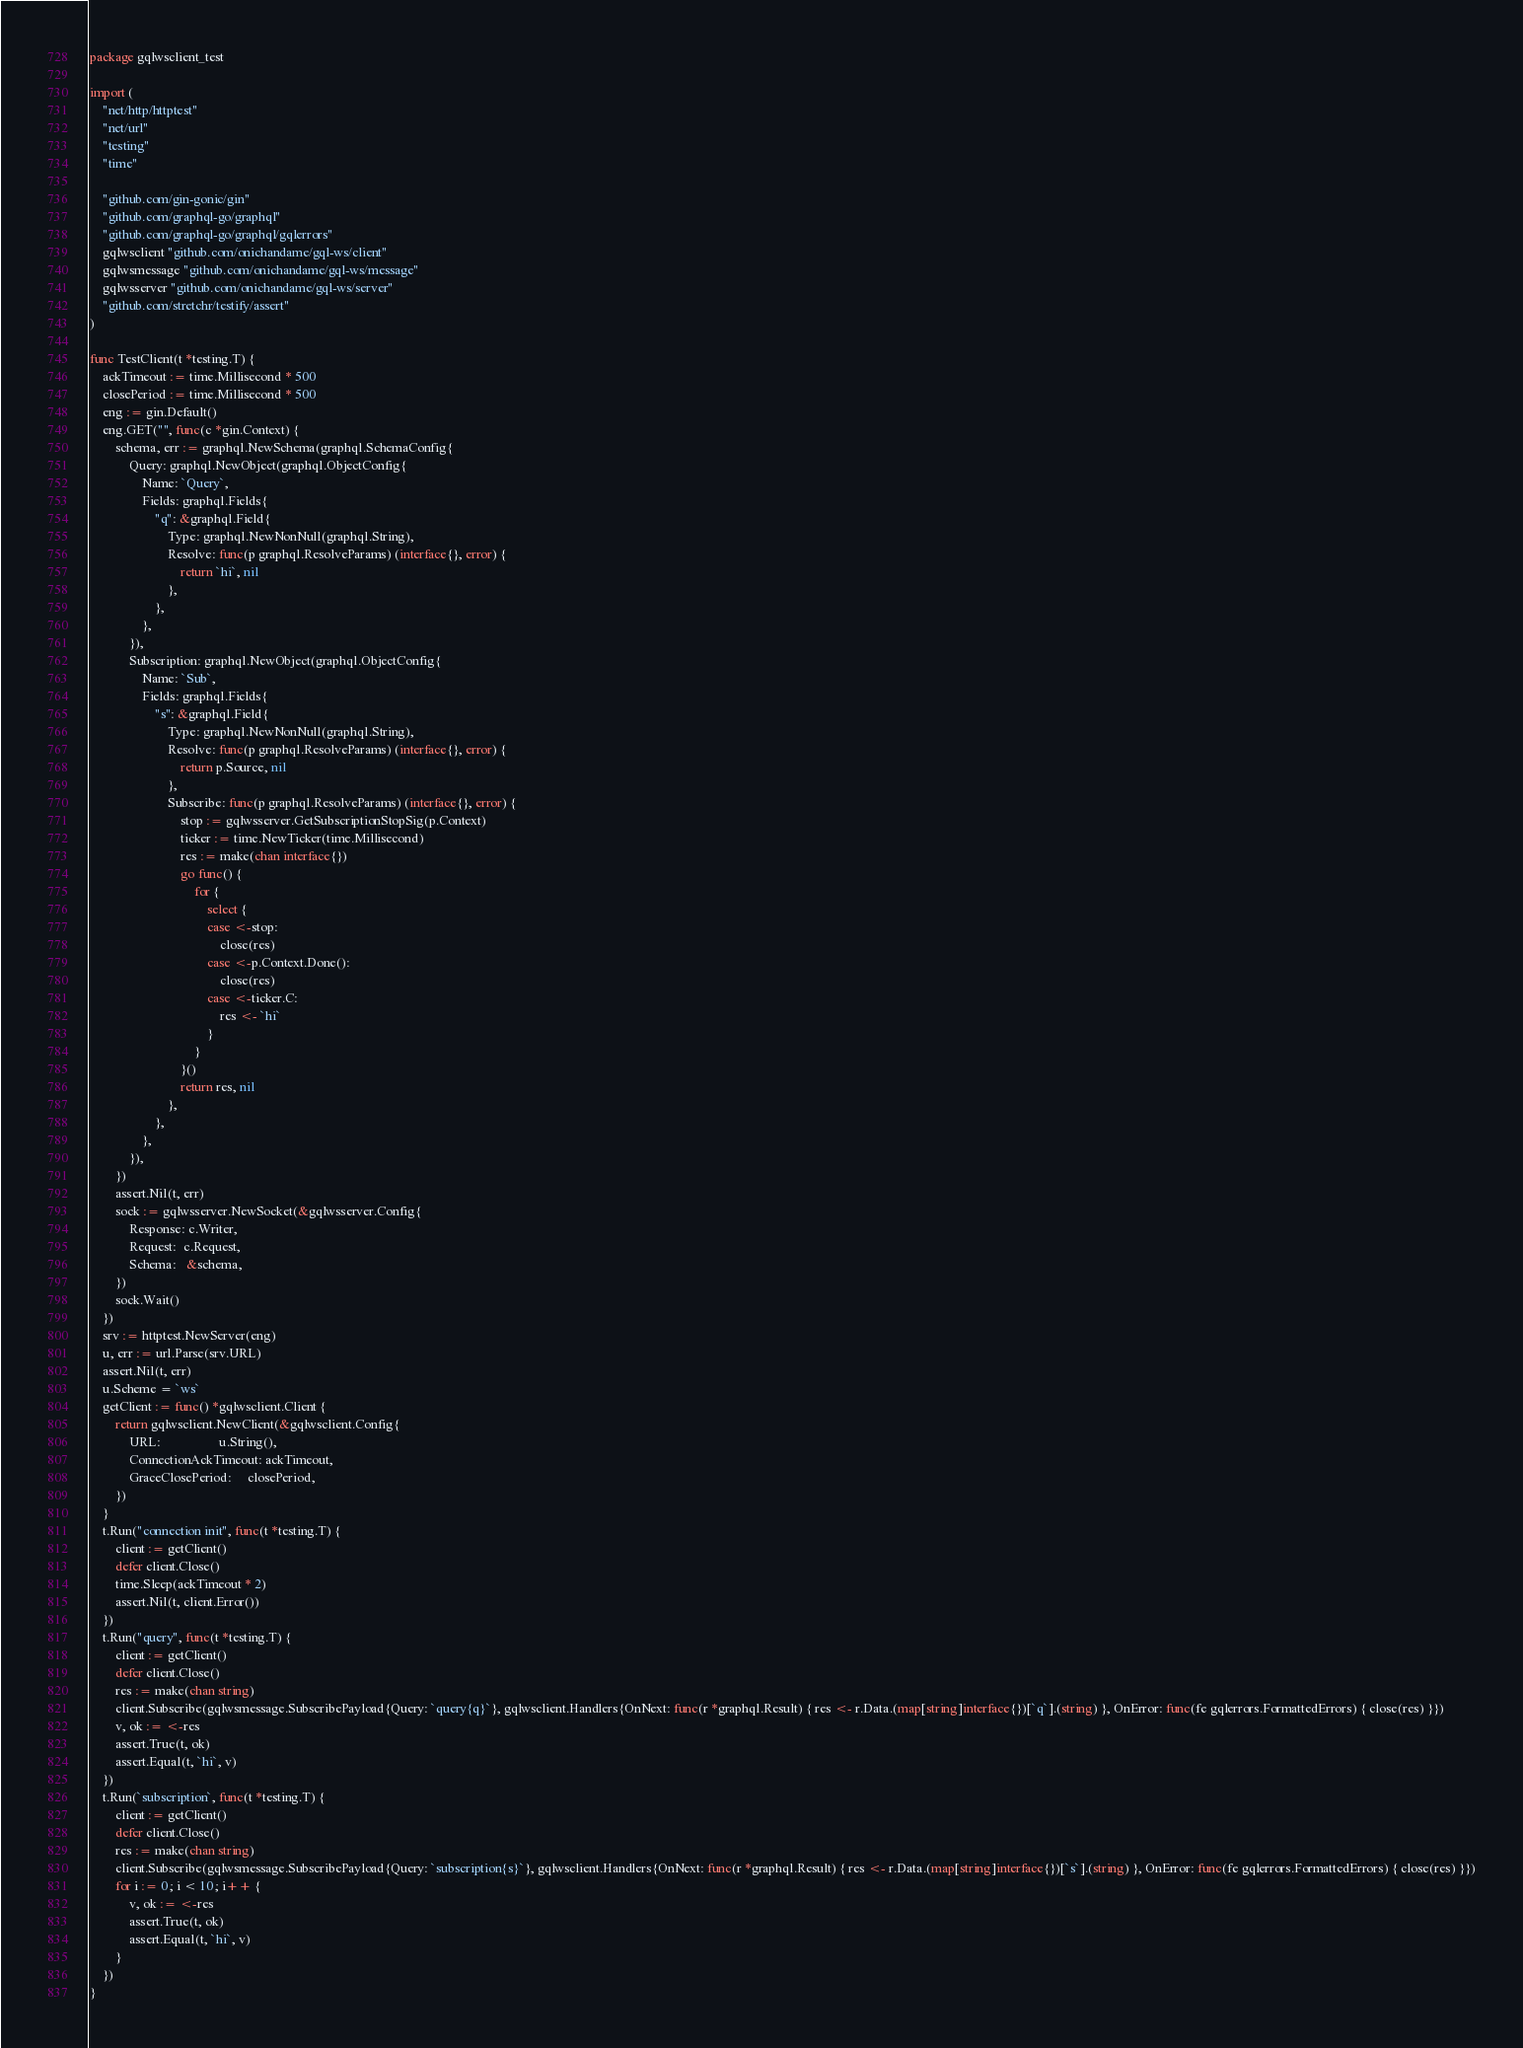Convert code to text. <code><loc_0><loc_0><loc_500><loc_500><_Go_>package gqlwsclient_test

import (
	"net/http/httptest"
	"net/url"
	"testing"
	"time"

	"github.com/gin-gonic/gin"
	"github.com/graphql-go/graphql"
	"github.com/graphql-go/graphql/gqlerrors"
	gqlwsclient "github.com/onichandame/gql-ws/client"
	gqlwsmessage "github.com/onichandame/gql-ws/message"
	gqlwsserver "github.com/onichandame/gql-ws/server"
	"github.com/stretchr/testify/assert"
)

func TestClient(t *testing.T) {
	ackTimeout := time.Millisecond * 500
	closePeriod := time.Millisecond * 500
	eng := gin.Default()
	eng.GET("", func(c *gin.Context) {
		schema, err := graphql.NewSchema(graphql.SchemaConfig{
			Query: graphql.NewObject(graphql.ObjectConfig{
				Name: `Query`,
				Fields: graphql.Fields{
					"q": &graphql.Field{
						Type: graphql.NewNonNull(graphql.String),
						Resolve: func(p graphql.ResolveParams) (interface{}, error) {
							return `hi`, nil
						},
					},
				},
			}),
			Subscription: graphql.NewObject(graphql.ObjectConfig{
				Name: `Sub`,
				Fields: graphql.Fields{
					"s": &graphql.Field{
						Type: graphql.NewNonNull(graphql.String),
						Resolve: func(p graphql.ResolveParams) (interface{}, error) {
							return p.Source, nil
						},
						Subscribe: func(p graphql.ResolveParams) (interface{}, error) {
							stop := gqlwsserver.GetSubscriptionStopSig(p.Context)
							ticker := time.NewTicker(time.Millisecond)
							res := make(chan interface{})
							go func() {
								for {
									select {
									case <-stop:
										close(res)
									case <-p.Context.Done():
										close(res)
									case <-ticker.C:
										res <- `hi`
									}
								}
							}()
							return res, nil
						},
					},
				},
			}),
		})
		assert.Nil(t, err)
		sock := gqlwsserver.NewSocket(&gqlwsserver.Config{
			Response: c.Writer,
			Request:  c.Request,
			Schema:   &schema,
		})
		sock.Wait()
	})
	srv := httptest.NewServer(eng)
	u, err := url.Parse(srv.URL)
	assert.Nil(t, err)
	u.Scheme = `ws`
	getClient := func() *gqlwsclient.Client {
		return gqlwsclient.NewClient(&gqlwsclient.Config{
			URL:                  u.String(),
			ConnectionAckTimeout: ackTimeout,
			GraceClosePeriod:     closePeriod,
		})
	}
	t.Run("connection init", func(t *testing.T) {
		client := getClient()
		defer client.Close()
		time.Sleep(ackTimeout * 2)
		assert.Nil(t, client.Error())
	})
	t.Run("query", func(t *testing.T) {
		client := getClient()
		defer client.Close()
		res := make(chan string)
		client.Subscribe(gqlwsmessage.SubscribePayload{Query: `query{q}`}, gqlwsclient.Handlers{OnNext: func(r *graphql.Result) { res <- r.Data.(map[string]interface{})[`q`].(string) }, OnError: func(fe gqlerrors.FormattedErrors) { close(res) }})
		v, ok := <-res
		assert.True(t, ok)
		assert.Equal(t, `hi`, v)
	})
	t.Run(`subscription`, func(t *testing.T) {
		client := getClient()
		defer client.Close()
		res := make(chan string)
		client.Subscribe(gqlwsmessage.SubscribePayload{Query: `subscription{s}`}, gqlwsclient.Handlers{OnNext: func(r *graphql.Result) { res <- r.Data.(map[string]interface{})[`s`].(string) }, OnError: func(fe gqlerrors.FormattedErrors) { close(res) }})
		for i := 0; i < 10; i++ {
			v, ok := <-res
			assert.True(t, ok)
			assert.Equal(t, `hi`, v)
		}
	})
}
</code> 